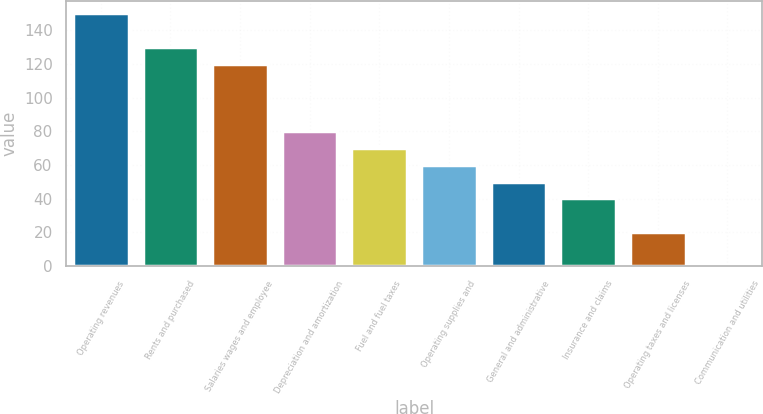<chart> <loc_0><loc_0><loc_500><loc_500><bar_chart><fcel>Operating revenues<fcel>Rents and purchased<fcel>Salaries wages and employee<fcel>Depreciation and amortization<fcel>Fuel and fuel taxes<fcel>Operating supplies and<fcel>General and administrative<fcel>Insurance and claims<fcel>Operating taxes and licenses<fcel>Communication and utilities<nl><fcel>149.85<fcel>129.91<fcel>119.94<fcel>80.06<fcel>70.09<fcel>60.12<fcel>50.15<fcel>40.18<fcel>20.24<fcel>0.3<nl></chart> 